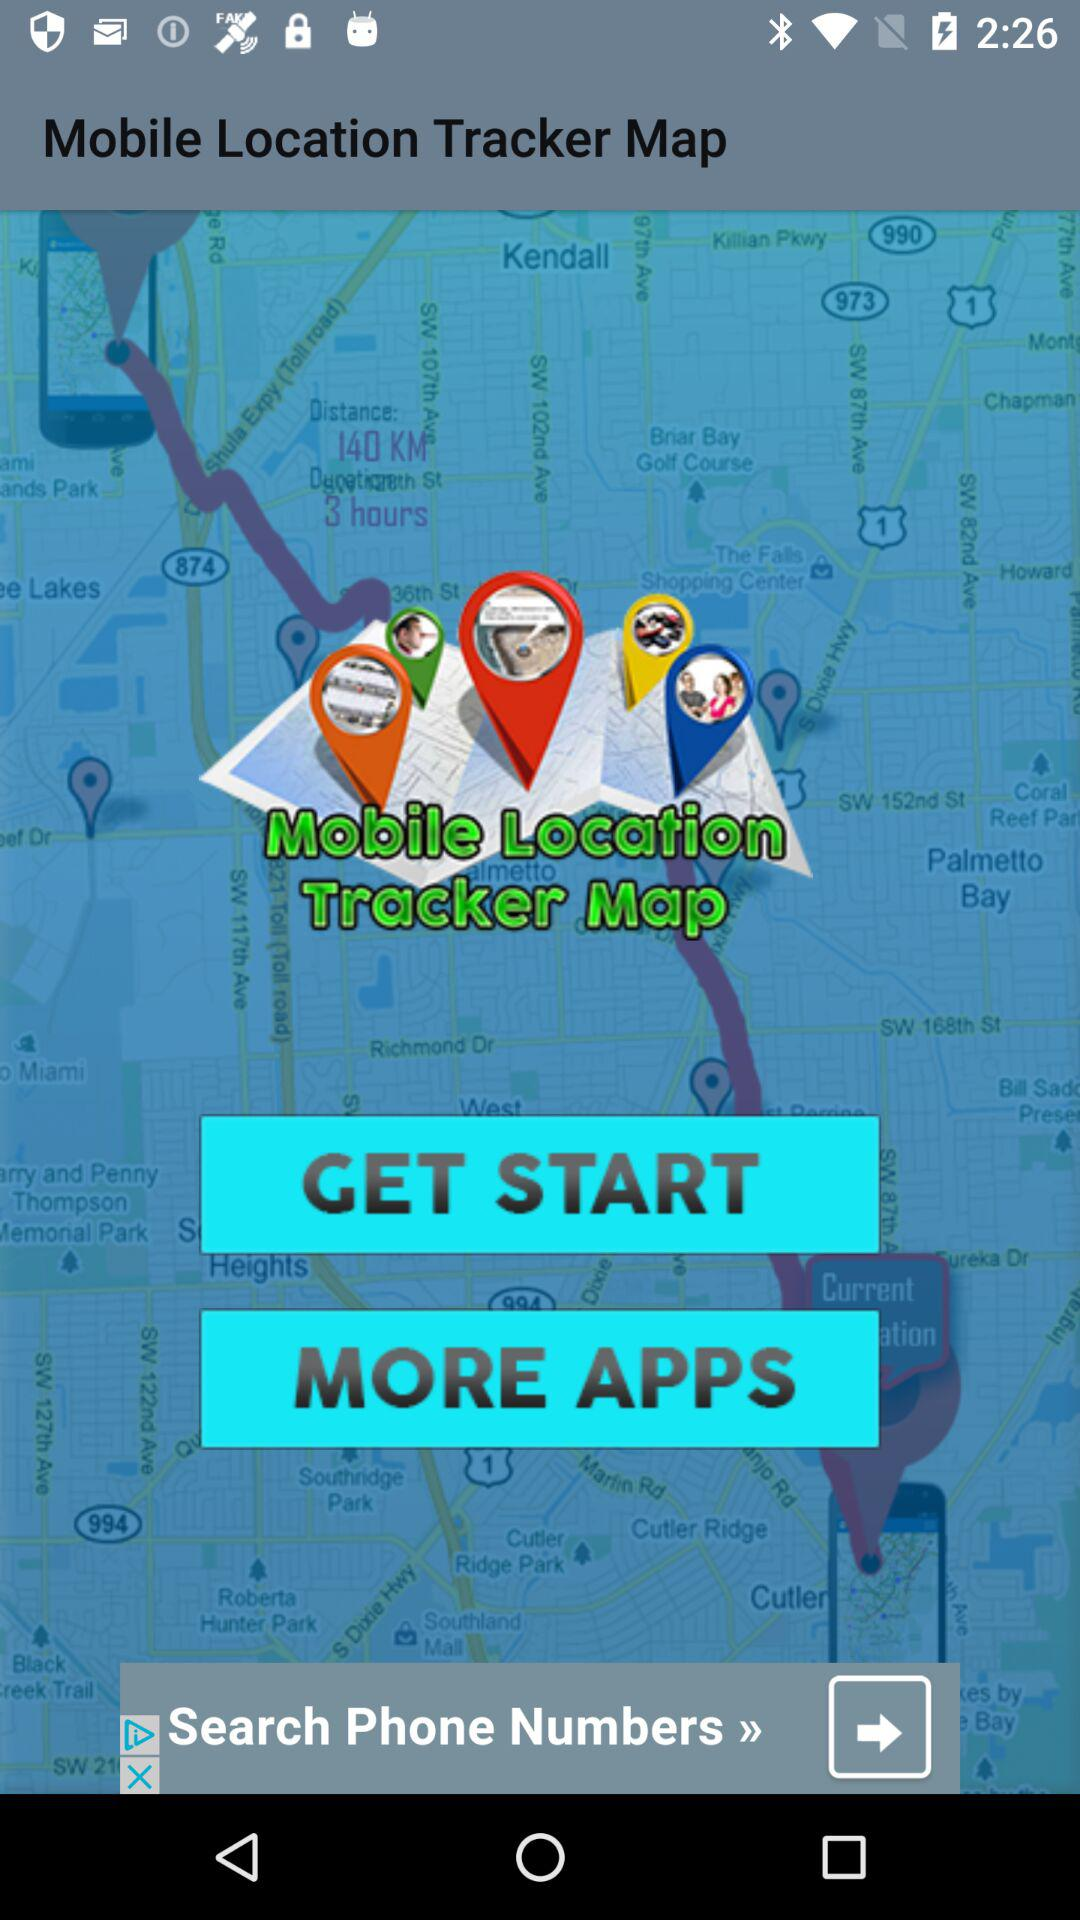When was the application last updated?
When the provided information is insufficient, respond with <no answer>. <no answer> 